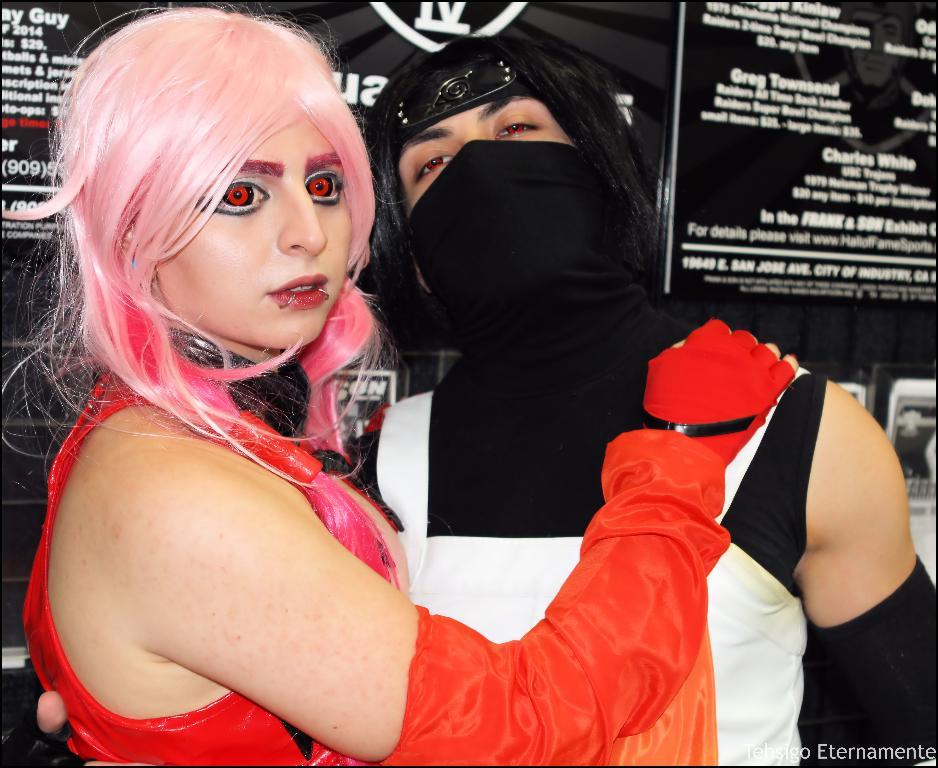<image>
Provide a brief description of the given image. Two people are in front of a banner that reads Charles White. 